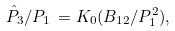<formula> <loc_0><loc_0><loc_500><loc_500>\hat { P } _ { 3 } / P _ { 1 } \, = K _ { 0 } ( B _ { 1 2 } / P _ { 1 } ^ { 2 } ) ,</formula> 